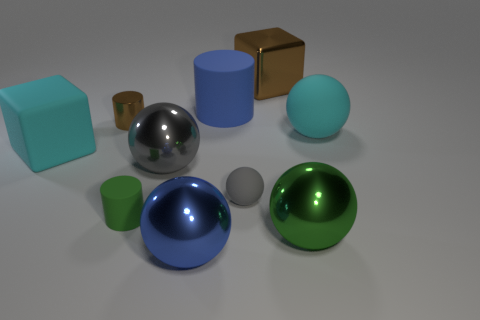How many cyan matte objects are left of the metal sphere behind the gray rubber ball?
Keep it short and to the point. 1. How many other things are there of the same shape as the large green shiny thing?
Your answer should be compact. 4. What number of things are large things or big metal things right of the big brown block?
Ensure brevity in your answer.  7. Is the number of big blue spheres that are in front of the green cylinder greater than the number of brown cylinders to the right of the large matte cylinder?
Offer a very short reply. Yes. The big object that is to the left of the brown object to the left of the small thing on the right side of the large blue metal ball is what shape?
Your response must be concise. Cube. There is a big cyan rubber thing that is in front of the big cyan object to the right of the green sphere; what is its shape?
Keep it short and to the point. Cube. Is there a tiny object that has the same material as the big brown block?
Your answer should be very brief. Yes. The metallic cylinder that is the same color as the shiny block is what size?
Give a very brief answer. Small. What number of cyan objects are either big matte cubes or tiny metallic cubes?
Offer a very short reply. 1. Are there any tiny objects of the same color as the shiny block?
Make the answer very short. Yes. 